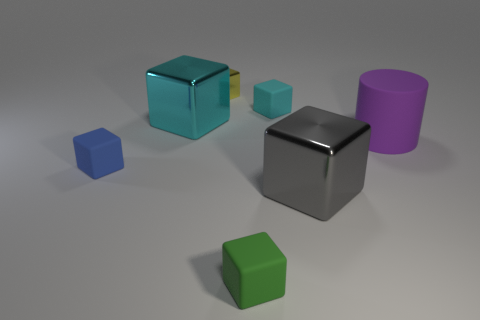Are the shadows consistent with a single light source? The shadows in the image appear to be consistent with a single light source, given their direction and lengths. They all extend away to the lower right, suggesting a light source located to the upper left. 